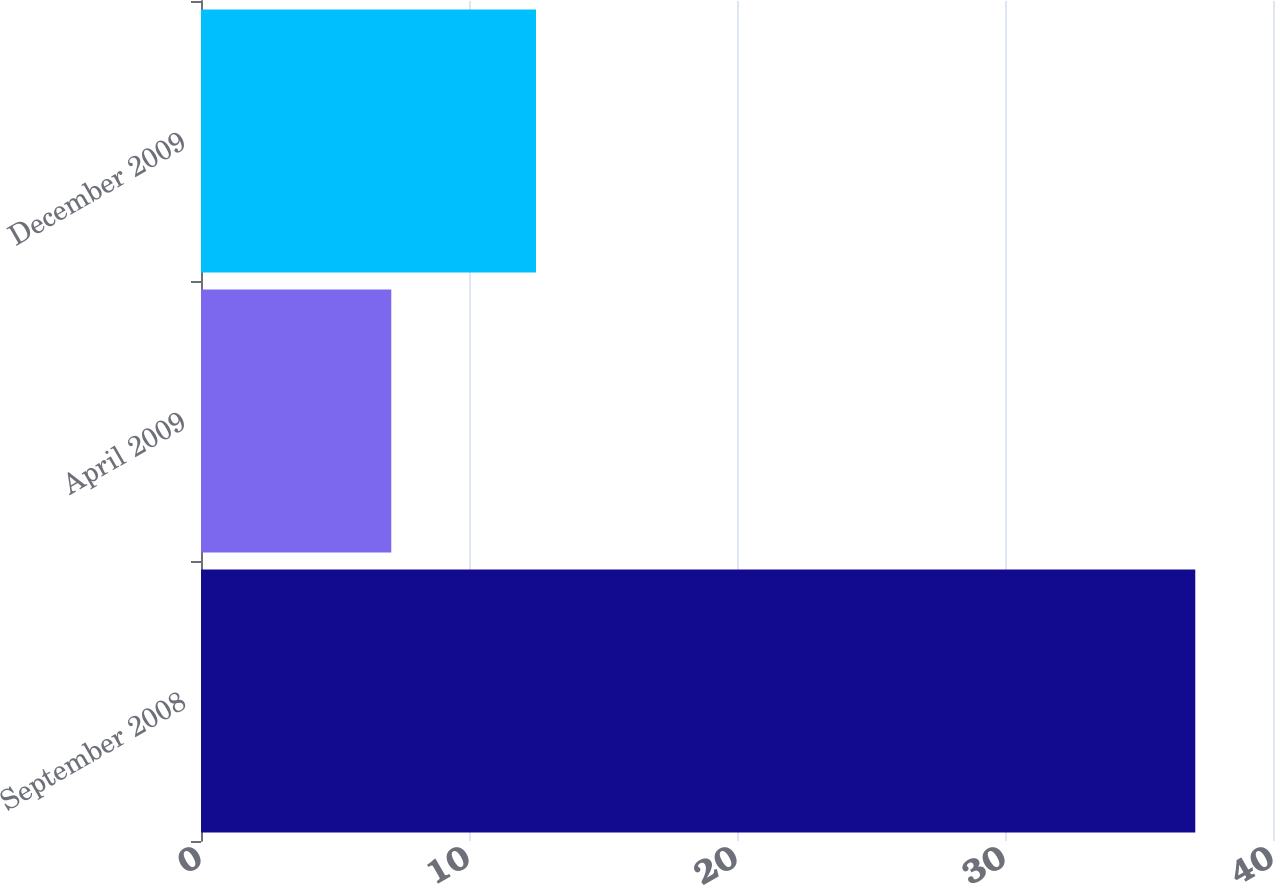<chart> <loc_0><loc_0><loc_500><loc_500><bar_chart><fcel>September 2008<fcel>April 2009<fcel>December 2009<nl><fcel>37.1<fcel>7.1<fcel>12.5<nl></chart> 